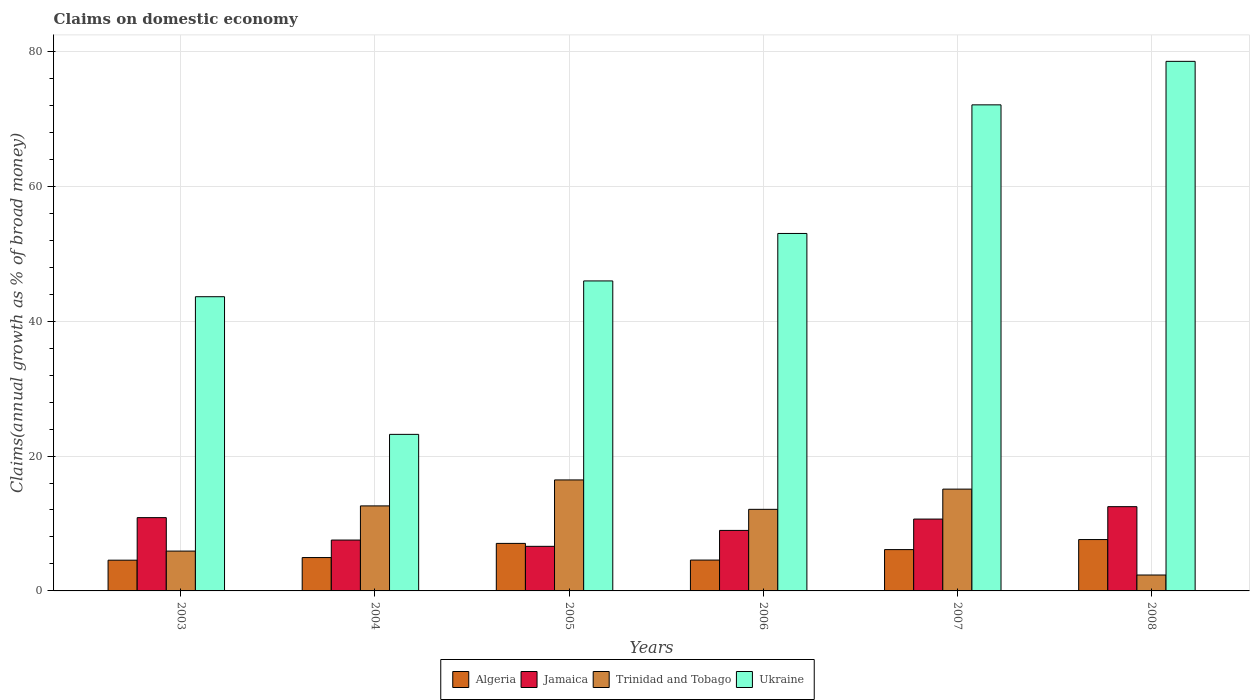How many different coloured bars are there?
Your answer should be compact. 4. Are the number of bars on each tick of the X-axis equal?
Provide a short and direct response. Yes. How many bars are there on the 3rd tick from the left?
Provide a short and direct response. 4. How many bars are there on the 6th tick from the right?
Provide a succinct answer. 4. In how many cases, is the number of bars for a given year not equal to the number of legend labels?
Keep it short and to the point. 0. What is the percentage of broad money claimed on domestic economy in Trinidad and Tobago in 2005?
Your answer should be very brief. 16.46. Across all years, what is the maximum percentage of broad money claimed on domestic economy in Trinidad and Tobago?
Provide a short and direct response. 16.46. Across all years, what is the minimum percentage of broad money claimed on domestic economy in Jamaica?
Provide a short and direct response. 6.61. In which year was the percentage of broad money claimed on domestic economy in Ukraine minimum?
Ensure brevity in your answer.  2004. What is the total percentage of broad money claimed on domestic economy in Jamaica in the graph?
Your answer should be compact. 57.14. What is the difference between the percentage of broad money claimed on domestic economy in Trinidad and Tobago in 2003 and that in 2004?
Give a very brief answer. -6.7. What is the difference between the percentage of broad money claimed on domestic economy in Ukraine in 2005 and the percentage of broad money claimed on domestic economy in Jamaica in 2003?
Ensure brevity in your answer.  35.1. What is the average percentage of broad money claimed on domestic economy in Algeria per year?
Ensure brevity in your answer.  5.81. In the year 2008, what is the difference between the percentage of broad money claimed on domestic economy in Ukraine and percentage of broad money claimed on domestic economy in Jamaica?
Your answer should be very brief. 66.03. In how many years, is the percentage of broad money claimed on domestic economy in Algeria greater than 32 %?
Offer a terse response. 0. What is the ratio of the percentage of broad money claimed on domestic economy in Trinidad and Tobago in 2003 to that in 2005?
Provide a succinct answer. 0.36. Is the difference between the percentage of broad money claimed on domestic economy in Ukraine in 2003 and 2005 greater than the difference between the percentage of broad money claimed on domestic economy in Jamaica in 2003 and 2005?
Make the answer very short. No. What is the difference between the highest and the second highest percentage of broad money claimed on domestic economy in Jamaica?
Your answer should be very brief. 1.63. What is the difference between the highest and the lowest percentage of broad money claimed on domestic economy in Ukraine?
Make the answer very short. 55.31. In how many years, is the percentage of broad money claimed on domestic economy in Ukraine greater than the average percentage of broad money claimed on domestic economy in Ukraine taken over all years?
Your answer should be very brief. 3. What does the 2nd bar from the left in 2004 represents?
Ensure brevity in your answer.  Jamaica. What does the 4th bar from the right in 2006 represents?
Provide a succinct answer. Algeria. Is it the case that in every year, the sum of the percentage of broad money claimed on domestic economy in Jamaica and percentage of broad money claimed on domestic economy in Algeria is greater than the percentage of broad money claimed on domestic economy in Ukraine?
Your answer should be very brief. No. How many bars are there?
Offer a terse response. 24. Are all the bars in the graph horizontal?
Keep it short and to the point. No. How many years are there in the graph?
Ensure brevity in your answer.  6. What is the difference between two consecutive major ticks on the Y-axis?
Your answer should be compact. 20. Are the values on the major ticks of Y-axis written in scientific E-notation?
Your response must be concise. No. Does the graph contain any zero values?
Provide a short and direct response. No. Does the graph contain grids?
Provide a succinct answer. Yes. Where does the legend appear in the graph?
Offer a very short reply. Bottom center. How many legend labels are there?
Make the answer very short. 4. How are the legend labels stacked?
Your answer should be compact. Horizontal. What is the title of the graph?
Keep it short and to the point. Claims on domestic economy. Does "Pacific island small states" appear as one of the legend labels in the graph?
Provide a short and direct response. No. What is the label or title of the X-axis?
Make the answer very short. Years. What is the label or title of the Y-axis?
Provide a short and direct response. Claims(annual growth as % of broad money). What is the Claims(annual growth as % of broad money) in Algeria in 2003?
Make the answer very short. 4.56. What is the Claims(annual growth as % of broad money) in Jamaica in 2003?
Give a very brief answer. 10.87. What is the Claims(annual growth as % of broad money) of Trinidad and Tobago in 2003?
Your answer should be compact. 5.91. What is the Claims(annual growth as % of broad money) of Ukraine in 2003?
Offer a terse response. 43.63. What is the Claims(annual growth as % of broad money) of Algeria in 2004?
Offer a terse response. 4.95. What is the Claims(annual growth as % of broad money) in Jamaica in 2004?
Offer a very short reply. 7.54. What is the Claims(annual growth as % of broad money) of Trinidad and Tobago in 2004?
Your answer should be compact. 12.61. What is the Claims(annual growth as % of broad money) in Ukraine in 2004?
Provide a succinct answer. 23.21. What is the Claims(annual growth as % of broad money) in Algeria in 2005?
Your answer should be very brief. 7.05. What is the Claims(annual growth as % of broad money) of Jamaica in 2005?
Keep it short and to the point. 6.61. What is the Claims(annual growth as % of broad money) of Trinidad and Tobago in 2005?
Keep it short and to the point. 16.46. What is the Claims(annual growth as % of broad money) in Ukraine in 2005?
Keep it short and to the point. 45.97. What is the Claims(annual growth as % of broad money) of Algeria in 2006?
Provide a short and direct response. 4.58. What is the Claims(annual growth as % of broad money) in Jamaica in 2006?
Your response must be concise. 8.97. What is the Claims(annual growth as % of broad money) in Trinidad and Tobago in 2006?
Provide a succinct answer. 12.1. What is the Claims(annual growth as % of broad money) of Ukraine in 2006?
Your answer should be compact. 53. What is the Claims(annual growth as % of broad money) in Algeria in 2007?
Make the answer very short. 6.13. What is the Claims(annual growth as % of broad money) in Jamaica in 2007?
Give a very brief answer. 10.65. What is the Claims(annual growth as % of broad money) of Trinidad and Tobago in 2007?
Give a very brief answer. 15.09. What is the Claims(annual growth as % of broad money) in Ukraine in 2007?
Provide a short and direct response. 72.08. What is the Claims(annual growth as % of broad money) in Algeria in 2008?
Ensure brevity in your answer.  7.62. What is the Claims(annual growth as % of broad money) in Jamaica in 2008?
Offer a very short reply. 12.49. What is the Claims(annual growth as % of broad money) of Trinidad and Tobago in 2008?
Make the answer very short. 2.36. What is the Claims(annual growth as % of broad money) in Ukraine in 2008?
Provide a succinct answer. 78.53. Across all years, what is the maximum Claims(annual growth as % of broad money) in Algeria?
Offer a very short reply. 7.62. Across all years, what is the maximum Claims(annual growth as % of broad money) of Jamaica?
Offer a terse response. 12.49. Across all years, what is the maximum Claims(annual growth as % of broad money) in Trinidad and Tobago?
Ensure brevity in your answer.  16.46. Across all years, what is the maximum Claims(annual growth as % of broad money) of Ukraine?
Offer a terse response. 78.53. Across all years, what is the minimum Claims(annual growth as % of broad money) of Algeria?
Your response must be concise. 4.56. Across all years, what is the minimum Claims(annual growth as % of broad money) in Jamaica?
Provide a short and direct response. 6.61. Across all years, what is the minimum Claims(annual growth as % of broad money) of Trinidad and Tobago?
Your answer should be compact. 2.36. Across all years, what is the minimum Claims(annual growth as % of broad money) of Ukraine?
Your answer should be very brief. 23.21. What is the total Claims(annual growth as % of broad money) of Algeria in the graph?
Keep it short and to the point. 34.87. What is the total Claims(annual growth as % of broad money) of Jamaica in the graph?
Ensure brevity in your answer.  57.14. What is the total Claims(annual growth as % of broad money) of Trinidad and Tobago in the graph?
Ensure brevity in your answer.  64.53. What is the total Claims(annual growth as % of broad money) of Ukraine in the graph?
Your answer should be very brief. 316.42. What is the difference between the Claims(annual growth as % of broad money) in Algeria in 2003 and that in 2004?
Offer a very short reply. -0.39. What is the difference between the Claims(annual growth as % of broad money) in Jamaica in 2003 and that in 2004?
Your answer should be compact. 3.33. What is the difference between the Claims(annual growth as % of broad money) in Trinidad and Tobago in 2003 and that in 2004?
Your answer should be very brief. -6.7. What is the difference between the Claims(annual growth as % of broad money) of Ukraine in 2003 and that in 2004?
Ensure brevity in your answer.  20.41. What is the difference between the Claims(annual growth as % of broad money) in Algeria in 2003 and that in 2005?
Provide a succinct answer. -2.49. What is the difference between the Claims(annual growth as % of broad money) of Jamaica in 2003 and that in 2005?
Your response must be concise. 4.26. What is the difference between the Claims(annual growth as % of broad money) in Trinidad and Tobago in 2003 and that in 2005?
Offer a very short reply. -10.55. What is the difference between the Claims(annual growth as % of broad money) in Ukraine in 2003 and that in 2005?
Your response must be concise. -2.34. What is the difference between the Claims(annual growth as % of broad money) of Algeria in 2003 and that in 2006?
Your response must be concise. -0.02. What is the difference between the Claims(annual growth as % of broad money) of Jamaica in 2003 and that in 2006?
Provide a short and direct response. 1.9. What is the difference between the Claims(annual growth as % of broad money) of Trinidad and Tobago in 2003 and that in 2006?
Provide a short and direct response. -6.19. What is the difference between the Claims(annual growth as % of broad money) of Ukraine in 2003 and that in 2006?
Offer a terse response. -9.38. What is the difference between the Claims(annual growth as % of broad money) in Algeria in 2003 and that in 2007?
Your answer should be compact. -1.57. What is the difference between the Claims(annual growth as % of broad money) in Jamaica in 2003 and that in 2007?
Ensure brevity in your answer.  0.21. What is the difference between the Claims(annual growth as % of broad money) of Trinidad and Tobago in 2003 and that in 2007?
Ensure brevity in your answer.  -9.19. What is the difference between the Claims(annual growth as % of broad money) of Ukraine in 2003 and that in 2007?
Offer a terse response. -28.45. What is the difference between the Claims(annual growth as % of broad money) in Algeria in 2003 and that in 2008?
Offer a very short reply. -3.06. What is the difference between the Claims(annual growth as % of broad money) in Jamaica in 2003 and that in 2008?
Make the answer very short. -1.63. What is the difference between the Claims(annual growth as % of broad money) in Trinidad and Tobago in 2003 and that in 2008?
Ensure brevity in your answer.  3.55. What is the difference between the Claims(annual growth as % of broad money) in Ukraine in 2003 and that in 2008?
Ensure brevity in your answer.  -34.9. What is the difference between the Claims(annual growth as % of broad money) in Algeria in 2004 and that in 2005?
Your response must be concise. -2.1. What is the difference between the Claims(annual growth as % of broad money) in Jamaica in 2004 and that in 2005?
Offer a terse response. 0.93. What is the difference between the Claims(annual growth as % of broad money) in Trinidad and Tobago in 2004 and that in 2005?
Your answer should be very brief. -3.85. What is the difference between the Claims(annual growth as % of broad money) of Ukraine in 2004 and that in 2005?
Give a very brief answer. -22.75. What is the difference between the Claims(annual growth as % of broad money) of Algeria in 2004 and that in 2006?
Make the answer very short. 0.37. What is the difference between the Claims(annual growth as % of broad money) of Jamaica in 2004 and that in 2006?
Give a very brief answer. -1.43. What is the difference between the Claims(annual growth as % of broad money) in Trinidad and Tobago in 2004 and that in 2006?
Your answer should be compact. 0.51. What is the difference between the Claims(annual growth as % of broad money) of Ukraine in 2004 and that in 2006?
Your response must be concise. -29.79. What is the difference between the Claims(annual growth as % of broad money) in Algeria in 2004 and that in 2007?
Make the answer very short. -1.18. What is the difference between the Claims(annual growth as % of broad money) in Jamaica in 2004 and that in 2007?
Ensure brevity in your answer.  -3.11. What is the difference between the Claims(annual growth as % of broad money) of Trinidad and Tobago in 2004 and that in 2007?
Your response must be concise. -2.49. What is the difference between the Claims(annual growth as % of broad money) in Ukraine in 2004 and that in 2007?
Give a very brief answer. -48.86. What is the difference between the Claims(annual growth as % of broad money) in Algeria in 2004 and that in 2008?
Give a very brief answer. -2.67. What is the difference between the Claims(annual growth as % of broad money) in Jamaica in 2004 and that in 2008?
Make the answer very short. -4.95. What is the difference between the Claims(annual growth as % of broad money) in Trinidad and Tobago in 2004 and that in 2008?
Provide a succinct answer. 10.25. What is the difference between the Claims(annual growth as % of broad money) of Ukraine in 2004 and that in 2008?
Ensure brevity in your answer.  -55.31. What is the difference between the Claims(annual growth as % of broad money) of Algeria in 2005 and that in 2006?
Keep it short and to the point. 2.47. What is the difference between the Claims(annual growth as % of broad money) of Jamaica in 2005 and that in 2006?
Offer a terse response. -2.36. What is the difference between the Claims(annual growth as % of broad money) in Trinidad and Tobago in 2005 and that in 2006?
Offer a terse response. 4.36. What is the difference between the Claims(annual growth as % of broad money) of Ukraine in 2005 and that in 2006?
Your response must be concise. -7.04. What is the difference between the Claims(annual growth as % of broad money) in Algeria in 2005 and that in 2007?
Offer a terse response. 0.92. What is the difference between the Claims(annual growth as % of broad money) of Jamaica in 2005 and that in 2007?
Your response must be concise. -4.04. What is the difference between the Claims(annual growth as % of broad money) of Trinidad and Tobago in 2005 and that in 2007?
Keep it short and to the point. 1.36. What is the difference between the Claims(annual growth as % of broad money) of Ukraine in 2005 and that in 2007?
Your response must be concise. -26.11. What is the difference between the Claims(annual growth as % of broad money) in Algeria in 2005 and that in 2008?
Keep it short and to the point. -0.57. What is the difference between the Claims(annual growth as % of broad money) in Jamaica in 2005 and that in 2008?
Your response must be concise. -5.88. What is the difference between the Claims(annual growth as % of broad money) of Trinidad and Tobago in 2005 and that in 2008?
Offer a very short reply. 14.1. What is the difference between the Claims(annual growth as % of broad money) of Ukraine in 2005 and that in 2008?
Provide a short and direct response. -32.56. What is the difference between the Claims(annual growth as % of broad money) of Algeria in 2006 and that in 2007?
Your answer should be compact. -1.55. What is the difference between the Claims(annual growth as % of broad money) in Jamaica in 2006 and that in 2007?
Your response must be concise. -1.68. What is the difference between the Claims(annual growth as % of broad money) of Trinidad and Tobago in 2006 and that in 2007?
Provide a succinct answer. -3. What is the difference between the Claims(annual growth as % of broad money) of Ukraine in 2006 and that in 2007?
Make the answer very short. -19.07. What is the difference between the Claims(annual growth as % of broad money) of Algeria in 2006 and that in 2008?
Provide a succinct answer. -3.04. What is the difference between the Claims(annual growth as % of broad money) of Jamaica in 2006 and that in 2008?
Your answer should be very brief. -3.52. What is the difference between the Claims(annual growth as % of broad money) of Trinidad and Tobago in 2006 and that in 2008?
Make the answer very short. 9.74. What is the difference between the Claims(annual growth as % of broad money) of Ukraine in 2006 and that in 2008?
Provide a short and direct response. -25.52. What is the difference between the Claims(annual growth as % of broad money) of Algeria in 2007 and that in 2008?
Provide a succinct answer. -1.49. What is the difference between the Claims(annual growth as % of broad money) of Jamaica in 2007 and that in 2008?
Offer a very short reply. -1.84. What is the difference between the Claims(annual growth as % of broad money) of Trinidad and Tobago in 2007 and that in 2008?
Ensure brevity in your answer.  12.73. What is the difference between the Claims(annual growth as % of broad money) in Ukraine in 2007 and that in 2008?
Offer a terse response. -6.45. What is the difference between the Claims(annual growth as % of broad money) of Algeria in 2003 and the Claims(annual growth as % of broad money) of Jamaica in 2004?
Keep it short and to the point. -2.98. What is the difference between the Claims(annual growth as % of broad money) in Algeria in 2003 and the Claims(annual growth as % of broad money) in Trinidad and Tobago in 2004?
Make the answer very short. -8.05. What is the difference between the Claims(annual growth as % of broad money) in Algeria in 2003 and the Claims(annual growth as % of broad money) in Ukraine in 2004?
Your answer should be very brief. -18.66. What is the difference between the Claims(annual growth as % of broad money) of Jamaica in 2003 and the Claims(annual growth as % of broad money) of Trinidad and Tobago in 2004?
Make the answer very short. -1.74. What is the difference between the Claims(annual growth as % of broad money) of Jamaica in 2003 and the Claims(annual growth as % of broad money) of Ukraine in 2004?
Offer a very short reply. -12.35. What is the difference between the Claims(annual growth as % of broad money) of Trinidad and Tobago in 2003 and the Claims(annual growth as % of broad money) of Ukraine in 2004?
Offer a terse response. -17.31. What is the difference between the Claims(annual growth as % of broad money) in Algeria in 2003 and the Claims(annual growth as % of broad money) in Jamaica in 2005?
Your answer should be very brief. -2.05. What is the difference between the Claims(annual growth as % of broad money) of Algeria in 2003 and the Claims(annual growth as % of broad money) of Trinidad and Tobago in 2005?
Make the answer very short. -11.9. What is the difference between the Claims(annual growth as % of broad money) in Algeria in 2003 and the Claims(annual growth as % of broad money) in Ukraine in 2005?
Ensure brevity in your answer.  -41.41. What is the difference between the Claims(annual growth as % of broad money) in Jamaica in 2003 and the Claims(annual growth as % of broad money) in Trinidad and Tobago in 2005?
Your answer should be very brief. -5.59. What is the difference between the Claims(annual growth as % of broad money) in Jamaica in 2003 and the Claims(annual growth as % of broad money) in Ukraine in 2005?
Offer a terse response. -35.1. What is the difference between the Claims(annual growth as % of broad money) of Trinidad and Tobago in 2003 and the Claims(annual growth as % of broad money) of Ukraine in 2005?
Make the answer very short. -40.06. What is the difference between the Claims(annual growth as % of broad money) in Algeria in 2003 and the Claims(annual growth as % of broad money) in Jamaica in 2006?
Keep it short and to the point. -4.41. What is the difference between the Claims(annual growth as % of broad money) of Algeria in 2003 and the Claims(annual growth as % of broad money) of Trinidad and Tobago in 2006?
Make the answer very short. -7.54. What is the difference between the Claims(annual growth as % of broad money) of Algeria in 2003 and the Claims(annual growth as % of broad money) of Ukraine in 2006?
Your answer should be compact. -48.45. What is the difference between the Claims(annual growth as % of broad money) in Jamaica in 2003 and the Claims(annual growth as % of broad money) in Trinidad and Tobago in 2006?
Make the answer very short. -1.23. What is the difference between the Claims(annual growth as % of broad money) in Jamaica in 2003 and the Claims(annual growth as % of broad money) in Ukraine in 2006?
Your response must be concise. -42.14. What is the difference between the Claims(annual growth as % of broad money) in Trinidad and Tobago in 2003 and the Claims(annual growth as % of broad money) in Ukraine in 2006?
Your answer should be compact. -47.1. What is the difference between the Claims(annual growth as % of broad money) in Algeria in 2003 and the Claims(annual growth as % of broad money) in Jamaica in 2007?
Make the answer very short. -6.1. What is the difference between the Claims(annual growth as % of broad money) of Algeria in 2003 and the Claims(annual growth as % of broad money) of Trinidad and Tobago in 2007?
Your answer should be very brief. -10.54. What is the difference between the Claims(annual growth as % of broad money) in Algeria in 2003 and the Claims(annual growth as % of broad money) in Ukraine in 2007?
Ensure brevity in your answer.  -67.52. What is the difference between the Claims(annual growth as % of broad money) in Jamaica in 2003 and the Claims(annual growth as % of broad money) in Trinidad and Tobago in 2007?
Give a very brief answer. -4.23. What is the difference between the Claims(annual growth as % of broad money) in Jamaica in 2003 and the Claims(annual growth as % of broad money) in Ukraine in 2007?
Keep it short and to the point. -61.21. What is the difference between the Claims(annual growth as % of broad money) in Trinidad and Tobago in 2003 and the Claims(annual growth as % of broad money) in Ukraine in 2007?
Make the answer very short. -66.17. What is the difference between the Claims(annual growth as % of broad money) of Algeria in 2003 and the Claims(annual growth as % of broad money) of Jamaica in 2008?
Offer a very short reply. -7.94. What is the difference between the Claims(annual growth as % of broad money) in Algeria in 2003 and the Claims(annual growth as % of broad money) in Trinidad and Tobago in 2008?
Your answer should be compact. 2.2. What is the difference between the Claims(annual growth as % of broad money) of Algeria in 2003 and the Claims(annual growth as % of broad money) of Ukraine in 2008?
Your response must be concise. -73.97. What is the difference between the Claims(annual growth as % of broad money) of Jamaica in 2003 and the Claims(annual growth as % of broad money) of Trinidad and Tobago in 2008?
Offer a terse response. 8.51. What is the difference between the Claims(annual growth as % of broad money) of Jamaica in 2003 and the Claims(annual growth as % of broad money) of Ukraine in 2008?
Provide a short and direct response. -67.66. What is the difference between the Claims(annual growth as % of broad money) in Trinidad and Tobago in 2003 and the Claims(annual growth as % of broad money) in Ukraine in 2008?
Offer a very short reply. -72.62. What is the difference between the Claims(annual growth as % of broad money) in Algeria in 2004 and the Claims(annual growth as % of broad money) in Jamaica in 2005?
Your answer should be very brief. -1.66. What is the difference between the Claims(annual growth as % of broad money) in Algeria in 2004 and the Claims(annual growth as % of broad money) in Trinidad and Tobago in 2005?
Give a very brief answer. -11.51. What is the difference between the Claims(annual growth as % of broad money) in Algeria in 2004 and the Claims(annual growth as % of broad money) in Ukraine in 2005?
Your answer should be very brief. -41.02. What is the difference between the Claims(annual growth as % of broad money) in Jamaica in 2004 and the Claims(annual growth as % of broad money) in Trinidad and Tobago in 2005?
Provide a succinct answer. -8.91. What is the difference between the Claims(annual growth as % of broad money) of Jamaica in 2004 and the Claims(annual growth as % of broad money) of Ukraine in 2005?
Offer a terse response. -38.42. What is the difference between the Claims(annual growth as % of broad money) in Trinidad and Tobago in 2004 and the Claims(annual growth as % of broad money) in Ukraine in 2005?
Ensure brevity in your answer.  -33.36. What is the difference between the Claims(annual growth as % of broad money) in Algeria in 2004 and the Claims(annual growth as % of broad money) in Jamaica in 2006?
Your answer should be compact. -4.03. What is the difference between the Claims(annual growth as % of broad money) in Algeria in 2004 and the Claims(annual growth as % of broad money) in Trinidad and Tobago in 2006?
Provide a short and direct response. -7.15. What is the difference between the Claims(annual growth as % of broad money) in Algeria in 2004 and the Claims(annual growth as % of broad money) in Ukraine in 2006?
Keep it short and to the point. -48.06. What is the difference between the Claims(annual growth as % of broad money) of Jamaica in 2004 and the Claims(annual growth as % of broad money) of Trinidad and Tobago in 2006?
Your answer should be compact. -4.56. What is the difference between the Claims(annual growth as % of broad money) of Jamaica in 2004 and the Claims(annual growth as % of broad money) of Ukraine in 2006?
Give a very brief answer. -45.46. What is the difference between the Claims(annual growth as % of broad money) of Trinidad and Tobago in 2004 and the Claims(annual growth as % of broad money) of Ukraine in 2006?
Give a very brief answer. -40.4. What is the difference between the Claims(annual growth as % of broad money) in Algeria in 2004 and the Claims(annual growth as % of broad money) in Jamaica in 2007?
Give a very brief answer. -5.71. What is the difference between the Claims(annual growth as % of broad money) of Algeria in 2004 and the Claims(annual growth as % of broad money) of Trinidad and Tobago in 2007?
Make the answer very short. -10.15. What is the difference between the Claims(annual growth as % of broad money) in Algeria in 2004 and the Claims(annual growth as % of broad money) in Ukraine in 2007?
Give a very brief answer. -67.13. What is the difference between the Claims(annual growth as % of broad money) of Jamaica in 2004 and the Claims(annual growth as % of broad money) of Trinidad and Tobago in 2007?
Keep it short and to the point. -7.55. What is the difference between the Claims(annual growth as % of broad money) in Jamaica in 2004 and the Claims(annual growth as % of broad money) in Ukraine in 2007?
Provide a succinct answer. -64.54. What is the difference between the Claims(annual growth as % of broad money) in Trinidad and Tobago in 2004 and the Claims(annual growth as % of broad money) in Ukraine in 2007?
Your response must be concise. -59.47. What is the difference between the Claims(annual growth as % of broad money) of Algeria in 2004 and the Claims(annual growth as % of broad money) of Jamaica in 2008?
Keep it short and to the point. -7.55. What is the difference between the Claims(annual growth as % of broad money) of Algeria in 2004 and the Claims(annual growth as % of broad money) of Trinidad and Tobago in 2008?
Your response must be concise. 2.59. What is the difference between the Claims(annual growth as % of broad money) in Algeria in 2004 and the Claims(annual growth as % of broad money) in Ukraine in 2008?
Provide a short and direct response. -73.58. What is the difference between the Claims(annual growth as % of broad money) of Jamaica in 2004 and the Claims(annual growth as % of broad money) of Trinidad and Tobago in 2008?
Offer a very short reply. 5.18. What is the difference between the Claims(annual growth as % of broad money) in Jamaica in 2004 and the Claims(annual growth as % of broad money) in Ukraine in 2008?
Your response must be concise. -70.98. What is the difference between the Claims(annual growth as % of broad money) of Trinidad and Tobago in 2004 and the Claims(annual growth as % of broad money) of Ukraine in 2008?
Your answer should be very brief. -65.92. What is the difference between the Claims(annual growth as % of broad money) in Algeria in 2005 and the Claims(annual growth as % of broad money) in Jamaica in 2006?
Ensure brevity in your answer.  -1.93. What is the difference between the Claims(annual growth as % of broad money) in Algeria in 2005 and the Claims(annual growth as % of broad money) in Trinidad and Tobago in 2006?
Offer a terse response. -5.05. What is the difference between the Claims(annual growth as % of broad money) of Algeria in 2005 and the Claims(annual growth as % of broad money) of Ukraine in 2006?
Ensure brevity in your answer.  -45.96. What is the difference between the Claims(annual growth as % of broad money) in Jamaica in 2005 and the Claims(annual growth as % of broad money) in Trinidad and Tobago in 2006?
Keep it short and to the point. -5.49. What is the difference between the Claims(annual growth as % of broad money) of Jamaica in 2005 and the Claims(annual growth as % of broad money) of Ukraine in 2006?
Make the answer very short. -46.39. What is the difference between the Claims(annual growth as % of broad money) in Trinidad and Tobago in 2005 and the Claims(annual growth as % of broad money) in Ukraine in 2006?
Offer a very short reply. -36.55. What is the difference between the Claims(annual growth as % of broad money) in Algeria in 2005 and the Claims(annual growth as % of broad money) in Jamaica in 2007?
Make the answer very short. -3.61. What is the difference between the Claims(annual growth as % of broad money) of Algeria in 2005 and the Claims(annual growth as % of broad money) of Trinidad and Tobago in 2007?
Your response must be concise. -8.05. What is the difference between the Claims(annual growth as % of broad money) in Algeria in 2005 and the Claims(annual growth as % of broad money) in Ukraine in 2007?
Your answer should be compact. -65.03. What is the difference between the Claims(annual growth as % of broad money) in Jamaica in 2005 and the Claims(annual growth as % of broad money) in Trinidad and Tobago in 2007?
Offer a terse response. -8.48. What is the difference between the Claims(annual growth as % of broad money) of Jamaica in 2005 and the Claims(annual growth as % of broad money) of Ukraine in 2007?
Provide a short and direct response. -65.47. What is the difference between the Claims(annual growth as % of broad money) in Trinidad and Tobago in 2005 and the Claims(annual growth as % of broad money) in Ukraine in 2007?
Your answer should be compact. -55.62. What is the difference between the Claims(annual growth as % of broad money) of Algeria in 2005 and the Claims(annual growth as % of broad money) of Jamaica in 2008?
Your response must be concise. -5.45. What is the difference between the Claims(annual growth as % of broad money) in Algeria in 2005 and the Claims(annual growth as % of broad money) in Trinidad and Tobago in 2008?
Offer a terse response. 4.69. What is the difference between the Claims(annual growth as % of broad money) in Algeria in 2005 and the Claims(annual growth as % of broad money) in Ukraine in 2008?
Ensure brevity in your answer.  -71.48. What is the difference between the Claims(annual growth as % of broad money) in Jamaica in 2005 and the Claims(annual growth as % of broad money) in Trinidad and Tobago in 2008?
Your response must be concise. 4.25. What is the difference between the Claims(annual growth as % of broad money) of Jamaica in 2005 and the Claims(annual growth as % of broad money) of Ukraine in 2008?
Give a very brief answer. -71.92. What is the difference between the Claims(annual growth as % of broad money) in Trinidad and Tobago in 2005 and the Claims(annual growth as % of broad money) in Ukraine in 2008?
Ensure brevity in your answer.  -62.07. What is the difference between the Claims(annual growth as % of broad money) of Algeria in 2006 and the Claims(annual growth as % of broad money) of Jamaica in 2007?
Make the answer very short. -6.08. What is the difference between the Claims(annual growth as % of broad money) in Algeria in 2006 and the Claims(annual growth as % of broad money) in Trinidad and Tobago in 2007?
Provide a succinct answer. -10.52. What is the difference between the Claims(annual growth as % of broad money) in Algeria in 2006 and the Claims(annual growth as % of broad money) in Ukraine in 2007?
Offer a terse response. -67.5. What is the difference between the Claims(annual growth as % of broad money) of Jamaica in 2006 and the Claims(annual growth as % of broad money) of Trinidad and Tobago in 2007?
Give a very brief answer. -6.12. What is the difference between the Claims(annual growth as % of broad money) of Jamaica in 2006 and the Claims(annual growth as % of broad money) of Ukraine in 2007?
Your answer should be very brief. -63.11. What is the difference between the Claims(annual growth as % of broad money) in Trinidad and Tobago in 2006 and the Claims(annual growth as % of broad money) in Ukraine in 2007?
Your response must be concise. -59.98. What is the difference between the Claims(annual growth as % of broad money) in Algeria in 2006 and the Claims(annual growth as % of broad money) in Jamaica in 2008?
Your answer should be very brief. -7.92. What is the difference between the Claims(annual growth as % of broad money) in Algeria in 2006 and the Claims(annual growth as % of broad money) in Trinidad and Tobago in 2008?
Your answer should be compact. 2.22. What is the difference between the Claims(annual growth as % of broad money) of Algeria in 2006 and the Claims(annual growth as % of broad money) of Ukraine in 2008?
Provide a succinct answer. -73.95. What is the difference between the Claims(annual growth as % of broad money) of Jamaica in 2006 and the Claims(annual growth as % of broad money) of Trinidad and Tobago in 2008?
Your response must be concise. 6.61. What is the difference between the Claims(annual growth as % of broad money) in Jamaica in 2006 and the Claims(annual growth as % of broad money) in Ukraine in 2008?
Provide a succinct answer. -69.55. What is the difference between the Claims(annual growth as % of broad money) in Trinidad and Tobago in 2006 and the Claims(annual growth as % of broad money) in Ukraine in 2008?
Offer a very short reply. -66.43. What is the difference between the Claims(annual growth as % of broad money) of Algeria in 2007 and the Claims(annual growth as % of broad money) of Jamaica in 2008?
Your response must be concise. -6.37. What is the difference between the Claims(annual growth as % of broad money) in Algeria in 2007 and the Claims(annual growth as % of broad money) in Trinidad and Tobago in 2008?
Offer a very short reply. 3.77. What is the difference between the Claims(annual growth as % of broad money) in Algeria in 2007 and the Claims(annual growth as % of broad money) in Ukraine in 2008?
Your response must be concise. -72.4. What is the difference between the Claims(annual growth as % of broad money) in Jamaica in 2007 and the Claims(annual growth as % of broad money) in Trinidad and Tobago in 2008?
Provide a succinct answer. 8.29. What is the difference between the Claims(annual growth as % of broad money) of Jamaica in 2007 and the Claims(annual growth as % of broad money) of Ukraine in 2008?
Keep it short and to the point. -67.87. What is the difference between the Claims(annual growth as % of broad money) in Trinidad and Tobago in 2007 and the Claims(annual growth as % of broad money) in Ukraine in 2008?
Give a very brief answer. -63.43. What is the average Claims(annual growth as % of broad money) in Algeria per year?
Ensure brevity in your answer.  5.81. What is the average Claims(annual growth as % of broad money) in Jamaica per year?
Offer a terse response. 9.52. What is the average Claims(annual growth as % of broad money) of Trinidad and Tobago per year?
Your response must be concise. 10.75. What is the average Claims(annual growth as % of broad money) in Ukraine per year?
Offer a terse response. 52.74. In the year 2003, what is the difference between the Claims(annual growth as % of broad money) in Algeria and Claims(annual growth as % of broad money) in Jamaica?
Your answer should be compact. -6.31. In the year 2003, what is the difference between the Claims(annual growth as % of broad money) in Algeria and Claims(annual growth as % of broad money) in Trinidad and Tobago?
Offer a terse response. -1.35. In the year 2003, what is the difference between the Claims(annual growth as % of broad money) of Algeria and Claims(annual growth as % of broad money) of Ukraine?
Keep it short and to the point. -39.07. In the year 2003, what is the difference between the Claims(annual growth as % of broad money) in Jamaica and Claims(annual growth as % of broad money) in Trinidad and Tobago?
Provide a short and direct response. 4.96. In the year 2003, what is the difference between the Claims(annual growth as % of broad money) in Jamaica and Claims(annual growth as % of broad money) in Ukraine?
Make the answer very short. -32.76. In the year 2003, what is the difference between the Claims(annual growth as % of broad money) of Trinidad and Tobago and Claims(annual growth as % of broad money) of Ukraine?
Your response must be concise. -37.72. In the year 2004, what is the difference between the Claims(annual growth as % of broad money) of Algeria and Claims(annual growth as % of broad money) of Jamaica?
Offer a terse response. -2.59. In the year 2004, what is the difference between the Claims(annual growth as % of broad money) of Algeria and Claims(annual growth as % of broad money) of Trinidad and Tobago?
Your answer should be very brief. -7.66. In the year 2004, what is the difference between the Claims(annual growth as % of broad money) of Algeria and Claims(annual growth as % of broad money) of Ukraine?
Ensure brevity in your answer.  -18.27. In the year 2004, what is the difference between the Claims(annual growth as % of broad money) of Jamaica and Claims(annual growth as % of broad money) of Trinidad and Tobago?
Your answer should be compact. -5.07. In the year 2004, what is the difference between the Claims(annual growth as % of broad money) in Jamaica and Claims(annual growth as % of broad money) in Ukraine?
Your response must be concise. -15.67. In the year 2004, what is the difference between the Claims(annual growth as % of broad money) of Trinidad and Tobago and Claims(annual growth as % of broad money) of Ukraine?
Your answer should be compact. -10.61. In the year 2005, what is the difference between the Claims(annual growth as % of broad money) in Algeria and Claims(annual growth as % of broad money) in Jamaica?
Provide a succinct answer. 0.43. In the year 2005, what is the difference between the Claims(annual growth as % of broad money) in Algeria and Claims(annual growth as % of broad money) in Trinidad and Tobago?
Make the answer very short. -9.41. In the year 2005, what is the difference between the Claims(annual growth as % of broad money) of Algeria and Claims(annual growth as % of broad money) of Ukraine?
Your answer should be very brief. -38.92. In the year 2005, what is the difference between the Claims(annual growth as % of broad money) of Jamaica and Claims(annual growth as % of broad money) of Trinidad and Tobago?
Keep it short and to the point. -9.85. In the year 2005, what is the difference between the Claims(annual growth as % of broad money) in Jamaica and Claims(annual growth as % of broad money) in Ukraine?
Ensure brevity in your answer.  -39.36. In the year 2005, what is the difference between the Claims(annual growth as % of broad money) of Trinidad and Tobago and Claims(annual growth as % of broad money) of Ukraine?
Your response must be concise. -29.51. In the year 2006, what is the difference between the Claims(annual growth as % of broad money) of Algeria and Claims(annual growth as % of broad money) of Jamaica?
Give a very brief answer. -4.4. In the year 2006, what is the difference between the Claims(annual growth as % of broad money) in Algeria and Claims(annual growth as % of broad money) in Trinidad and Tobago?
Make the answer very short. -7.52. In the year 2006, what is the difference between the Claims(annual growth as % of broad money) in Algeria and Claims(annual growth as % of broad money) in Ukraine?
Keep it short and to the point. -48.43. In the year 2006, what is the difference between the Claims(annual growth as % of broad money) in Jamaica and Claims(annual growth as % of broad money) in Trinidad and Tobago?
Your answer should be compact. -3.13. In the year 2006, what is the difference between the Claims(annual growth as % of broad money) in Jamaica and Claims(annual growth as % of broad money) in Ukraine?
Offer a terse response. -44.03. In the year 2006, what is the difference between the Claims(annual growth as % of broad money) in Trinidad and Tobago and Claims(annual growth as % of broad money) in Ukraine?
Offer a very short reply. -40.91. In the year 2007, what is the difference between the Claims(annual growth as % of broad money) in Algeria and Claims(annual growth as % of broad money) in Jamaica?
Provide a succinct answer. -4.53. In the year 2007, what is the difference between the Claims(annual growth as % of broad money) in Algeria and Claims(annual growth as % of broad money) in Trinidad and Tobago?
Provide a succinct answer. -8.97. In the year 2007, what is the difference between the Claims(annual growth as % of broad money) of Algeria and Claims(annual growth as % of broad money) of Ukraine?
Ensure brevity in your answer.  -65.95. In the year 2007, what is the difference between the Claims(annual growth as % of broad money) of Jamaica and Claims(annual growth as % of broad money) of Trinidad and Tobago?
Provide a short and direct response. -4.44. In the year 2007, what is the difference between the Claims(annual growth as % of broad money) in Jamaica and Claims(annual growth as % of broad money) in Ukraine?
Offer a terse response. -61.42. In the year 2007, what is the difference between the Claims(annual growth as % of broad money) of Trinidad and Tobago and Claims(annual growth as % of broad money) of Ukraine?
Ensure brevity in your answer.  -56.98. In the year 2008, what is the difference between the Claims(annual growth as % of broad money) of Algeria and Claims(annual growth as % of broad money) of Jamaica?
Your answer should be very brief. -4.88. In the year 2008, what is the difference between the Claims(annual growth as % of broad money) in Algeria and Claims(annual growth as % of broad money) in Trinidad and Tobago?
Provide a short and direct response. 5.26. In the year 2008, what is the difference between the Claims(annual growth as % of broad money) of Algeria and Claims(annual growth as % of broad money) of Ukraine?
Ensure brevity in your answer.  -70.91. In the year 2008, what is the difference between the Claims(annual growth as % of broad money) of Jamaica and Claims(annual growth as % of broad money) of Trinidad and Tobago?
Give a very brief answer. 10.13. In the year 2008, what is the difference between the Claims(annual growth as % of broad money) in Jamaica and Claims(annual growth as % of broad money) in Ukraine?
Offer a very short reply. -66.03. In the year 2008, what is the difference between the Claims(annual growth as % of broad money) in Trinidad and Tobago and Claims(annual growth as % of broad money) in Ukraine?
Ensure brevity in your answer.  -76.17. What is the ratio of the Claims(annual growth as % of broad money) in Algeria in 2003 to that in 2004?
Provide a short and direct response. 0.92. What is the ratio of the Claims(annual growth as % of broad money) in Jamaica in 2003 to that in 2004?
Provide a short and direct response. 1.44. What is the ratio of the Claims(annual growth as % of broad money) in Trinidad and Tobago in 2003 to that in 2004?
Keep it short and to the point. 0.47. What is the ratio of the Claims(annual growth as % of broad money) of Ukraine in 2003 to that in 2004?
Give a very brief answer. 1.88. What is the ratio of the Claims(annual growth as % of broad money) in Algeria in 2003 to that in 2005?
Your answer should be compact. 0.65. What is the ratio of the Claims(annual growth as % of broad money) of Jamaica in 2003 to that in 2005?
Ensure brevity in your answer.  1.64. What is the ratio of the Claims(annual growth as % of broad money) of Trinidad and Tobago in 2003 to that in 2005?
Your response must be concise. 0.36. What is the ratio of the Claims(annual growth as % of broad money) in Ukraine in 2003 to that in 2005?
Your response must be concise. 0.95. What is the ratio of the Claims(annual growth as % of broad money) of Jamaica in 2003 to that in 2006?
Offer a very short reply. 1.21. What is the ratio of the Claims(annual growth as % of broad money) in Trinidad and Tobago in 2003 to that in 2006?
Keep it short and to the point. 0.49. What is the ratio of the Claims(annual growth as % of broad money) in Ukraine in 2003 to that in 2006?
Your answer should be very brief. 0.82. What is the ratio of the Claims(annual growth as % of broad money) in Algeria in 2003 to that in 2007?
Your answer should be compact. 0.74. What is the ratio of the Claims(annual growth as % of broad money) of Jamaica in 2003 to that in 2007?
Offer a very short reply. 1.02. What is the ratio of the Claims(annual growth as % of broad money) in Trinidad and Tobago in 2003 to that in 2007?
Offer a terse response. 0.39. What is the ratio of the Claims(annual growth as % of broad money) in Ukraine in 2003 to that in 2007?
Your answer should be compact. 0.61. What is the ratio of the Claims(annual growth as % of broad money) of Algeria in 2003 to that in 2008?
Your answer should be very brief. 0.6. What is the ratio of the Claims(annual growth as % of broad money) of Jamaica in 2003 to that in 2008?
Make the answer very short. 0.87. What is the ratio of the Claims(annual growth as % of broad money) of Trinidad and Tobago in 2003 to that in 2008?
Keep it short and to the point. 2.5. What is the ratio of the Claims(annual growth as % of broad money) in Ukraine in 2003 to that in 2008?
Your answer should be compact. 0.56. What is the ratio of the Claims(annual growth as % of broad money) in Algeria in 2004 to that in 2005?
Your response must be concise. 0.7. What is the ratio of the Claims(annual growth as % of broad money) in Jamaica in 2004 to that in 2005?
Offer a terse response. 1.14. What is the ratio of the Claims(annual growth as % of broad money) of Trinidad and Tobago in 2004 to that in 2005?
Keep it short and to the point. 0.77. What is the ratio of the Claims(annual growth as % of broad money) of Ukraine in 2004 to that in 2005?
Your answer should be compact. 0.51. What is the ratio of the Claims(annual growth as % of broad money) of Algeria in 2004 to that in 2006?
Offer a terse response. 1.08. What is the ratio of the Claims(annual growth as % of broad money) in Jamaica in 2004 to that in 2006?
Ensure brevity in your answer.  0.84. What is the ratio of the Claims(annual growth as % of broad money) in Trinidad and Tobago in 2004 to that in 2006?
Make the answer very short. 1.04. What is the ratio of the Claims(annual growth as % of broad money) in Ukraine in 2004 to that in 2006?
Offer a very short reply. 0.44. What is the ratio of the Claims(annual growth as % of broad money) in Algeria in 2004 to that in 2007?
Offer a terse response. 0.81. What is the ratio of the Claims(annual growth as % of broad money) in Jamaica in 2004 to that in 2007?
Give a very brief answer. 0.71. What is the ratio of the Claims(annual growth as % of broad money) in Trinidad and Tobago in 2004 to that in 2007?
Your answer should be compact. 0.84. What is the ratio of the Claims(annual growth as % of broad money) in Ukraine in 2004 to that in 2007?
Give a very brief answer. 0.32. What is the ratio of the Claims(annual growth as % of broad money) of Algeria in 2004 to that in 2008?
Keep it short and to the point. 0.65. What is the ratio of the Claims(annual growth as % of broad money) in Jamaica in 2004 to that in 2008?
Keep it short and to the point. 0.6. What is the ratio of the Claims(annual growth as % of broad money) in Trinidad and Tobago in 2004 to that in 2008?
Provide a succinct answer. 5.34. What is the ratio of the Claims(annual growth as % of broad money) of Ukraine in 2004 to that in 2008?
Provide a succinct answer. 0.3. What is the ratio of the Claims(annual growth as % of broad money) in Algeria in 2005 to that in 2006?
Offer a terse response. 1.54. What is the ratio of the Claims(annual growth as % of broad money) in Jamaica in 2005 to that in 2006?
Provide a short and direct response. 0.74. What is the ratio of the Claims(annual growth as % of broad money) of Trinidad and Tobago in 2005 to that in 2006?
Your answer should be very brief. 1.36. What is the ratio of the Claims(annual growth as % of broad money) of Ukraine in 2005 to that in 2006?
Your answer should be compact. 0.87. What is the ratio of the Claims(annual growth as % of broad money) of Algeria in 2005 to that in 2007?
Offer a terse response. 1.15. What is the ratio of the Claims(annual growth as % of broad money) in Jamaica in 2005 to that in 2007?
Provide a short and direct response. 0.62. What is the ratio of the Claims(annual growth as % of broad money) in Trinidad and Tobago in 2005 to that in 2007?
Your answer should be very brief. 1.09. What is the ratio of the Claims(annual growth as % of broad money) of Ukraine in 2005 to that in 2007?
Provide a short and direct response. 0.64. What is the ratio of the Claims(annual growth as % of broad money) in Algeria in 2005 to that in 2008?
Offer a terse response. 0.93. What is the ratio of the Claims(annual growth as % of broad money) in Jamaica in 2005 to that in 2008?
Give a very brief answer. 0.53. What is the ratio of the Claims(annual growth as % of broad money) in Trinidad and Tobago in 2005 to that in 2008?
Keep it short and to the point. 6.97. What is the ratio of the Claims(annual growth as % of broad money) in Ukraine in 2005 to that in 2008?
Your answer should be compact. 0.59. What is the ratio of the Claims(annual growth as % of broad money) in Algeria in 2006 to that in 2007?
Your response must be concise. 0.75. What is the ratio of the Claims(annual growth as % of broad money) of Jamaica in 2006 to that in 2007?
Offer a terse response. 0.84. What is the ratio of the Claims(annual growth as % of broad money) of Trinidad and Tobago in 2006 to that in 2007?
Provide a succinct answer. 0.8. What is the ratio of the Claims(annual growth as % of broad money) in Ukraine in 2006 to that in 2007?
Offer a very short reply. 0.74. What is the ratio of the Claims(annual growth as % of broad money) in Algeria in 2006 to that in 2008?
Ensure brevity in your answer.  0.6. What is the ratio of the Claims(annual growth as % of broad money) of Jamaica in 2006 to that in 2008?
Your answer should be compact. 0.72. What is the ratio of the Claims(annual growth as % of broad money) in Trinidad and Tobago in 2006 to that in 2008?
Your answer should be very brief. 5.13. What is the ratio of the Claims(annual growth as % of broad money) of Ukraine in 2006 to that in 2008?
Offer a terse response. 0.68. What is the ratio of the Claims(annual growth as % of broad money) of Algeria in 2007 to that in 2008?
Make the answer very short. 0.8. What is the ratio of the Claims(annual growth as % of broad money) in Jamaica in 2007 to that in 2008?
Keep it short and to the point. 0.85. What is the ratio of the Claims(annual growth as % of broad money) in Trinidad and Tobago in 2007 to that in 2008?
Provide a succinct answer. 6.4. What is the ratio of the Claims(annual growth as % of broad money) in Ukraine in 2007 to that in 2008?
Your answer should be very brief. 0.92. What is the difference between the highest and the second highest Claims(annual growth as % of broad money) of Algeria?
Offer a terse response. 0.57. What is the difference between the highest and the second highest Claims(annual growth as % of broad money) of Jamaica?
Provide a succinct answer. 1.63. What is the difference between the highest and the second highest Claims(annual growth as % of broad money) of Trinidad and Tobago?
Offer a terse response. 1.36. What is the difference between the highest and the second highest Claims(annual growth as % of broad money) in Ukraine?
Give a very brief answer. 6.45. What is the difference between the highest and the lowest Claims(annual growth as % of broad money) in Algeria?
Your answer should be very brief. 3.06. What is the difference between the highest and the lowest Claims(annual growth as % of broad money) in Jamaica?
Provide a succinct answer. 5.88. What is the difference between the highest and the lowest Claims(annual growth as % of broad money) of Trinidad and Tobago?
Offer a very short reply. 14.1. What is the difference between the highest and the lowest Claims(annual growth as % of broad money) in Ukraine?
Offer a terse response. 55.31. 